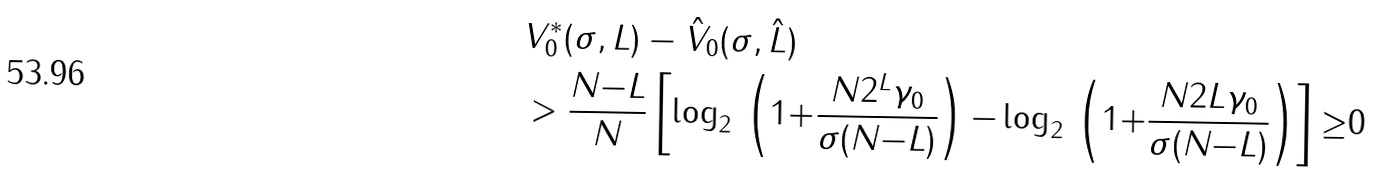Convert formula to latex. <formula><loc_0><loc_0><loc_500><loc_500>& V _ { 0 } ^ { * } ( \sigma , L ) - \hat { V } _ { 0 } ( \sigma , \hat { L } ) \\ & > \frac { N { - } L } { N } \left [ \log _ { 2 } \, \left ( 1 { + } \frac { N 2 ^ { L } \gamma _ { 0 } } { \sigma ( N { - } L ) } \right ) { - } \log _ { 2 } \, \left ( 1 { + } \frac { N 2 L \gamma _ { 0 } } { \sigma ( N { - } L ) } \right ) \right ] { \geq } 0</formula> 